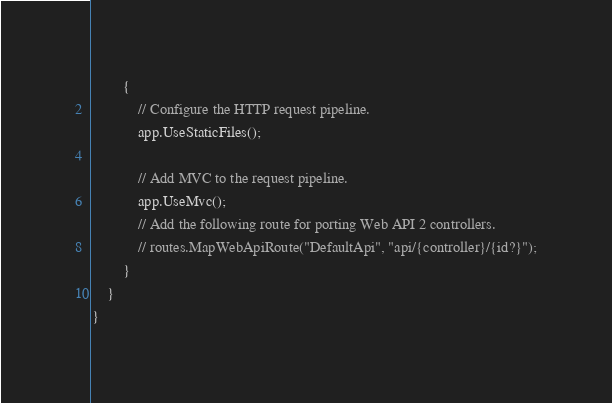Convert code to text. <code><loc_0><loc_0><loc_500><loc_500><_C#_>        {
            // Configure the HTTP request pipeline.
            app.UseStaticFiles();

            // Add MVC to the request pipeline.
            app.UseMvc();
            // Add the following route for porting Web API 2 controllers.
            // routes.MapWebApiRoute("DefaultApi", "api/{controller}/{id?}");
        }
    }
}
</code> 